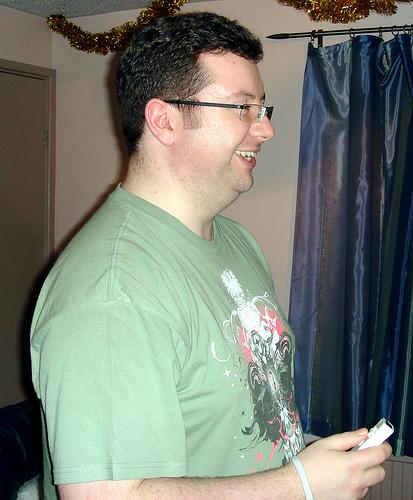Focus on the person's hairstyle and facial features in a short description of the image. The man with a visible ear, nose, and white teeth, as well as head hair, plays a video game while wearing glasses. Create a summary of the image, emphasizing the main subject's appearance. A happy man wearing thin black-framed glasses and a green t-shirt with a design is immersed in a video game. Write a concise narration of the image, with an emphasis on the person's emotions. A delighted man, wearing glasses and a green short-sleeved shirt, immerses himself in the captivating world of video games. Briefly describe the attire and any accessories worn by the person in the image. The man dons a green short-sleeved shirt featuring a design, thin black glasses, and a grey strap around his wrist. Construct a concise depiction of the image, highlighting the gaming device in use. A man is engaged in a video game, skillfully wielding a white controller in his hand and wearing glasses. Write a short description of the scene, focusing on the person's facial attributes. A man with a right ear, a visible nose, and white teeth in his mouth is sporting glasses while he smiles contentedly. Write a brief summary of the image, emphasizing the backdrop and surroundings. Amidst a blue couch and blue curtains in the background, a man wearing glasses is thoroughly enjoying a video game. Explain the situation in the image, paying special attention to the game controller the person is using. A man who's playing a game holds a white Wii controller with a grey strap attached to his wrist, a key gaming tool. Provide a brief description of the central figure in the image along with any notable features. A smiling man with glasses and a green short-sleeved shirt is playing a videogame using a white Wii controller. Mention the primary activity that the person in the image is engaged in. The man in the image is enthusiastically playing a video game with a white and black Wii remote. 